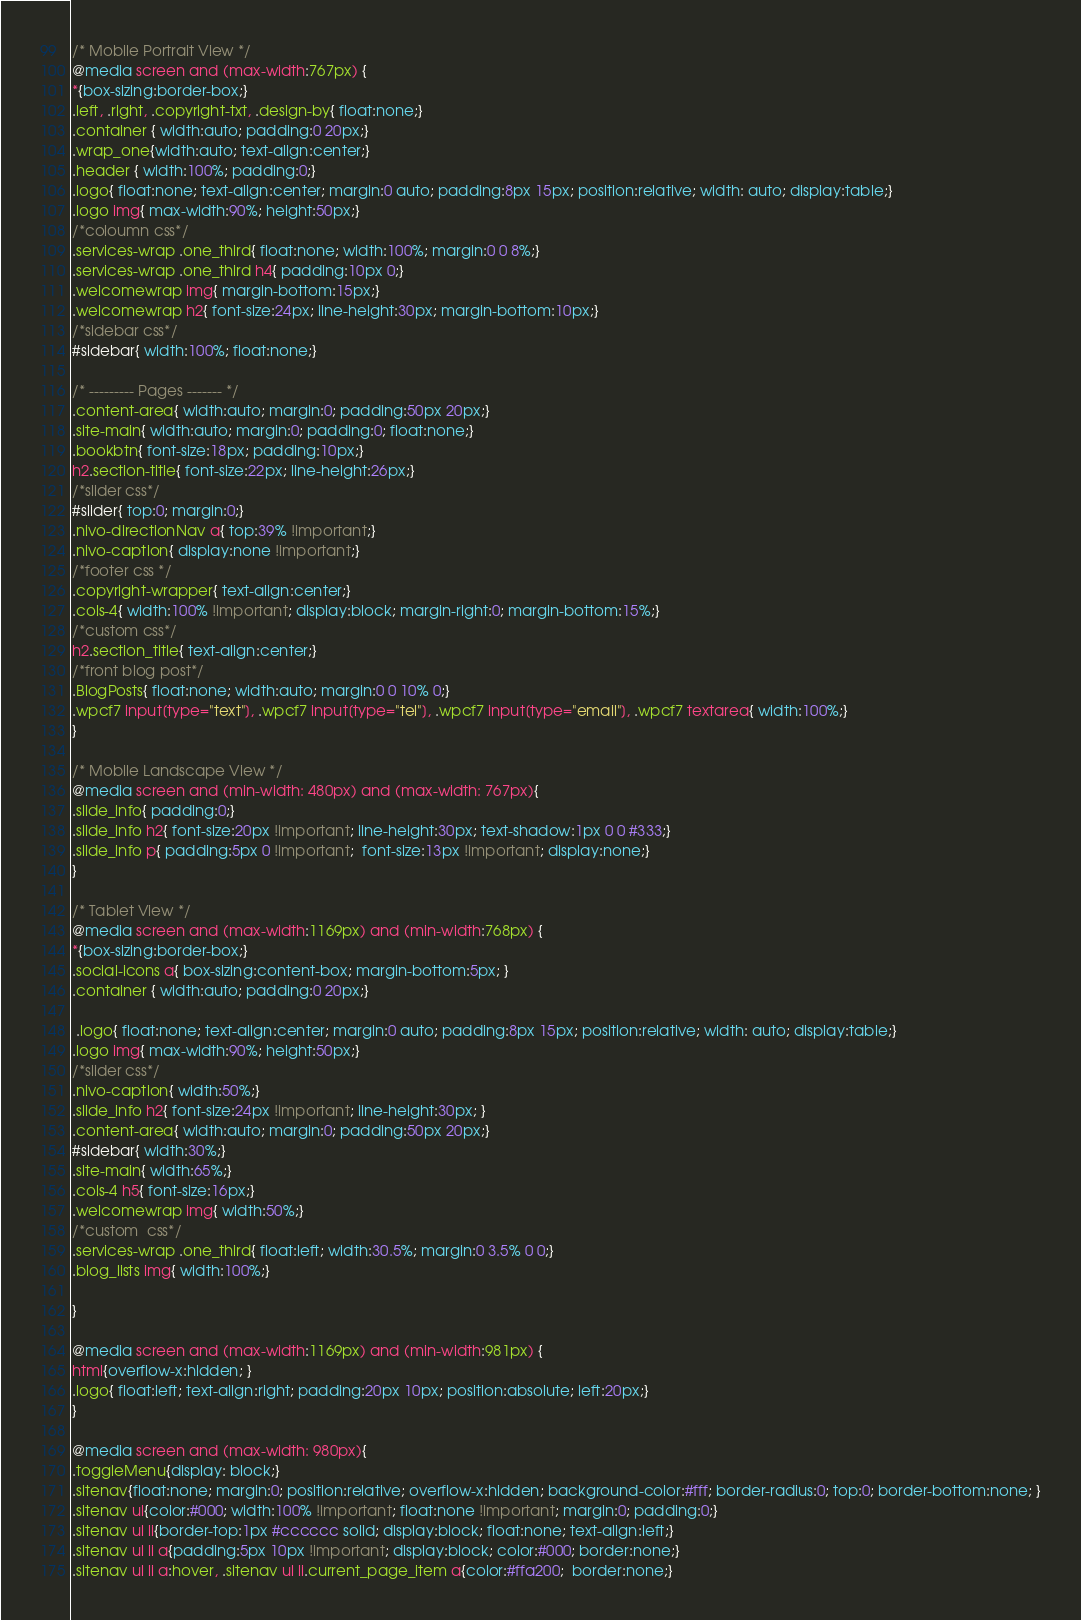<code> <loc_0><loc_0><loc_500><loc_500><_CSS_>/* Mobile Portrait View */
@media screen and (max-width:767px) {
*{box-sizing:border-box;}
.left, .right, .copyright-txt, .design-by{ float:none;}
.container { width:auto; padding:0 20px;}
.wrap_one{width:auto; text-align:center;}
.header { width:100%; padding:0;}
.logo{ float:none; text-align:center; margin:0 auto; padding:8px 15px; position:relative; width: auto; display:table;}
.logo img{ max-width:90%; height:50px;}
/*coloumn css*/
.services-wrap .one_third{ float:none; width:100%; margin:0 0 8%;}
.services-wrap .one_third h4{ padding:10px 0;}
.welcomewrap img{ margin-bottom:15px;}
.welcomewrap h2{ font-size:24px; line-height:30px; margin-bottom:10px;}
/*sidebar css*/
#sidebar{ width:100%; float:none;}

/* --------- Pages ------- */
.content-area{ width:auto; margin:0; padding:50px 20px;}
.site-main{ width:auto; margin:0; padding:0; float:none;}
.bookbtn{ font-size:18px; padding:10px;}
h2.section-title{ font-size:22px; line-height:26px;}
/*slider css*/
#slider{ top:0; margin:0;}
.nivo-directionNav a{ top:39% !important;}
.nivo-caption{ display:none !important;}
/*footer css */
.copyright-wrapper{ text-align:center;}
.cols-4{ width:100% !important; display:block; margin-right:0; margin-bottom:15%;}
/*custom css*/
h2.section_title{ text-align:center;}
/*front blog post*/
.BlogPosts{ float:none; width:auto; margin:0 0 10% 0;}
.wpcf7 input[type="text"], .wpcf7 input[type="tel"], .wpcf7 input[type="email"], .wpcf7 textarea{ width:100%;}
}

/* Mobile Landscape View */
@media screen and (min-width: 480px) and (max-width: 767px){
.slide_info{ padding:0;}
.slide_info h2{ font-size:20px !important; line-height:30px; text-shadow:1px 0 0 #333;}
.slide_info p{ padding:5px 0 !important;  font-size:13px !important; display:none;}
}

/* Tablet View */
@media screen and (max-width:1169px) and (min-width:768px) { 
*{box-sizing:border-box;}
.social-icons a{ box-sizing:content-box; margin-bottom:5px; }
.container { width:auto; padding:0 20px;}

 .logo{ float:none; text-align:center; margin:0 auto; padding:8px 15px; position:relative; width: auto; display:table;}
.logo img{ max-width:90%; height:50px;}
/*slider css*/
.nivo-caption{ width:50%;}
.slide_info h2{ font-size:24px !important; line-height:30px; }
.content-area{ width:auto; margin:0; padding:50px 20px;}
#sidebar{ width:30%;}
.site-main{ width:65%;}
.cols-4 h5{ font-size:16px;}
.welcomewrap img{ width:50%;}
/*custom  css*/
.services-wrap .one_third{ float:left; width:30.5%; margin:0 3.5% 0 0;}
.blog_lists img{ width:100%;}

}

@media screen and (max-width:1169px) and (min-width:981px) { 
html{overflow-x:hidden; }
.logo{ float:left; text-align:right; padding:20px 10px; position:absolute; left:20px;}
}

@media screen and (max-width: 980px){
.toggleMenu{display: block;}
.sitenav{float:none; margin:0; position:relative; overflow-x:hidden; background-color:#fff; border-radius:0; top:0; border-bottom:none; }
.sitenav ul{color:#000; width:100% !important; float:none !important; margin:0; padding:0;}
.sitenav ul li{border-top:1px #cccccc solid; display:block; float:none; text-align:left;}
.sitenav ul li a{padding:5px 10px !important; display:block; color:#000; border:none;}
.sitenav ul li a:hover, .sitenav ul li.current_page_item a{color:#ffa200;  border:none;}</code> 